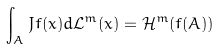<formula> <loc_0><loc_0><loc_500><loc_500>\int _ { A } J f ( x ) d \mathcal { L } ^ { m } ( x ) = \mathcal { H } ^ { m } ( f ( A ) )</formula> 